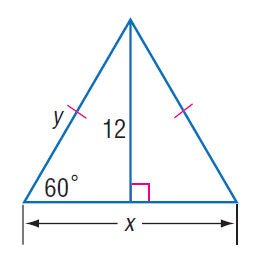Answer the mathemtical geometry problem and directly provide the correct option letter.
Question: Find x.
Choices: A: 6 B: 4 \sqrt { 3 } C: 12 D: 8 \sqrt { 3 } D 